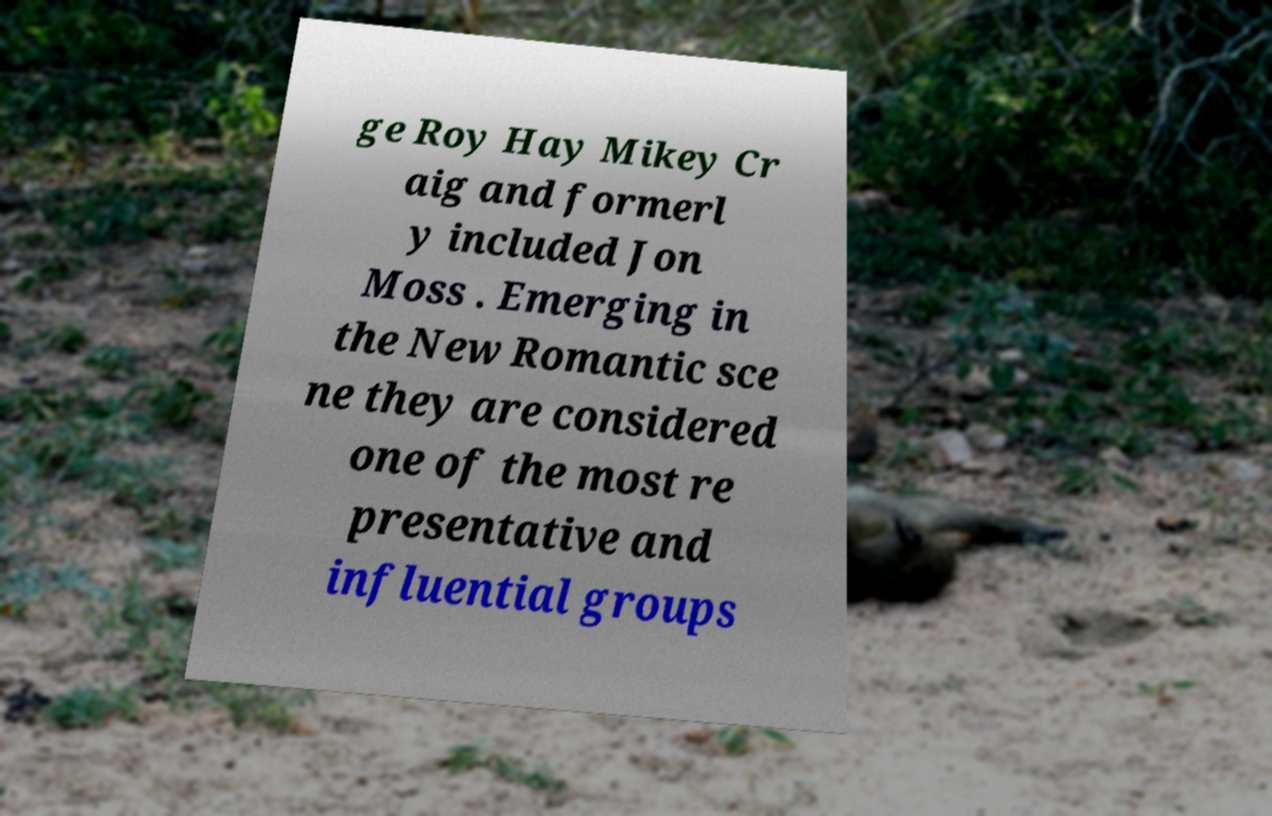There's text embedded in this image that I need extracted. Can you transcribe it verbatim? ge Roy Hay Mikey Cr aig and formerl y included Jon Moss . Emerging in the New Romantic sce ne they are considered one of the most re presentative and influential groups 